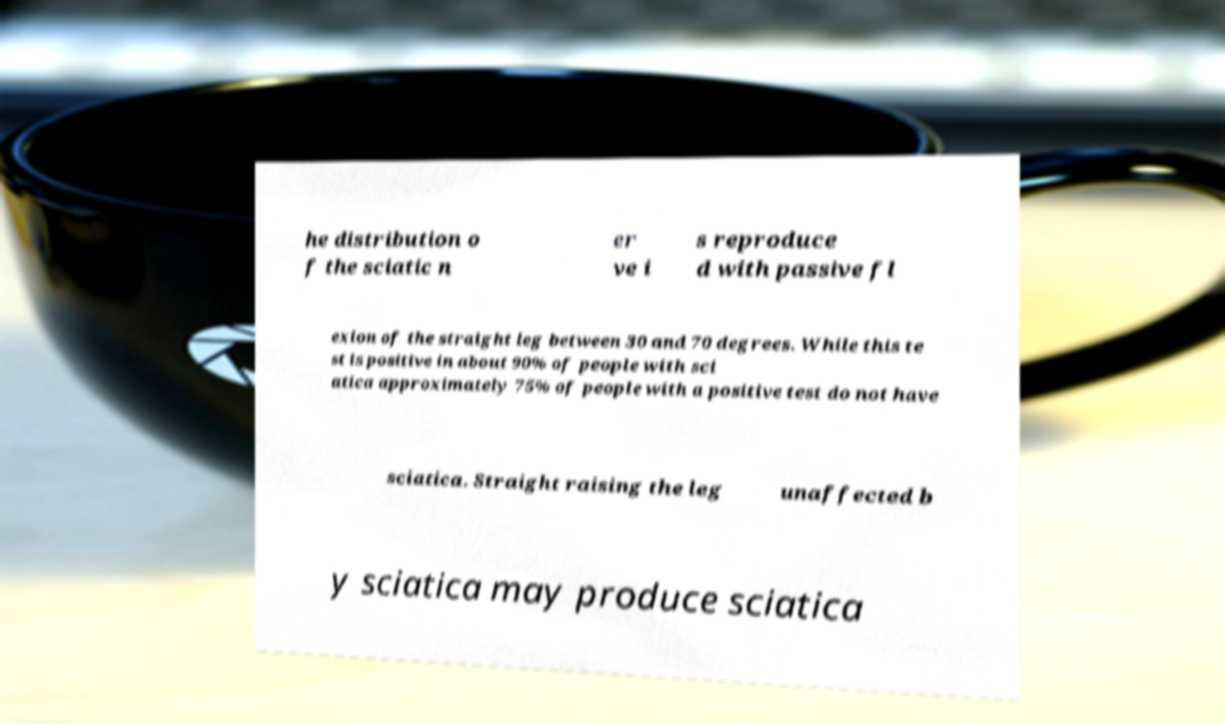For documentation purposes, I need the text within this image transcribed. Could you provide that? he distribution o f the sciatic n er ve i s reproduce d with passive fl exion of the straight leg between 30 and 70 degrees. While this te st is positive in about 90% of people with sci atica approximately 75% of people with a positive test do not have sciatica. Straight raising the leg unaffected b y sciatica may produce sciatica 